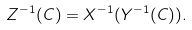<formula> <loc_0><loc_0><loc_500><loc_500>Z ^ { - 1 } ( C ) = X ^ { - 1 } ( Y ^ { - 1 } ( C ) ) .</formula> 